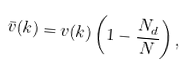<formula> <loc_0><loc_0><loc_500><loc_500>\bar { v } ( { k } ) = v ( { k } ) \left ( 1 - \frac { N _ { d } } { N } \right ) ,</formula> 